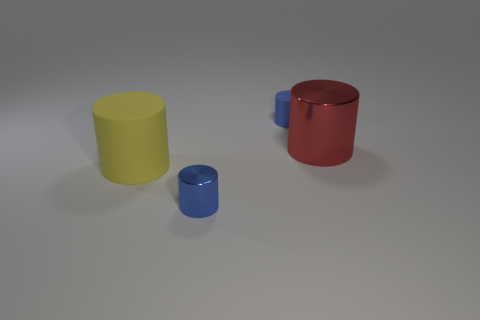Subtract all large yellow cylinders. How many cylinders are left? 3 Subtract all red cylinders. How many cylinders are left? 3 Add 1 cyan cylinders. How many objects exist? 5 Subtract all gray balls. How many blue cylinders are left? 2 Add 3 red things. How many red things exist? 4 Subtract 0 gray cylinders. How many objects are left? 4 Subtract 3 cylinders. How many cylinders are left? 1 Subtract all cyan cylinders. Subtract all blue cubes. How many cylinders are left? 4 Subtract all small cyan shiny cylinders. Subtract all yellow things. How many objects are left? 3 Add 2 tiny blue matte things. How many tiny blue matte things are left? 3 